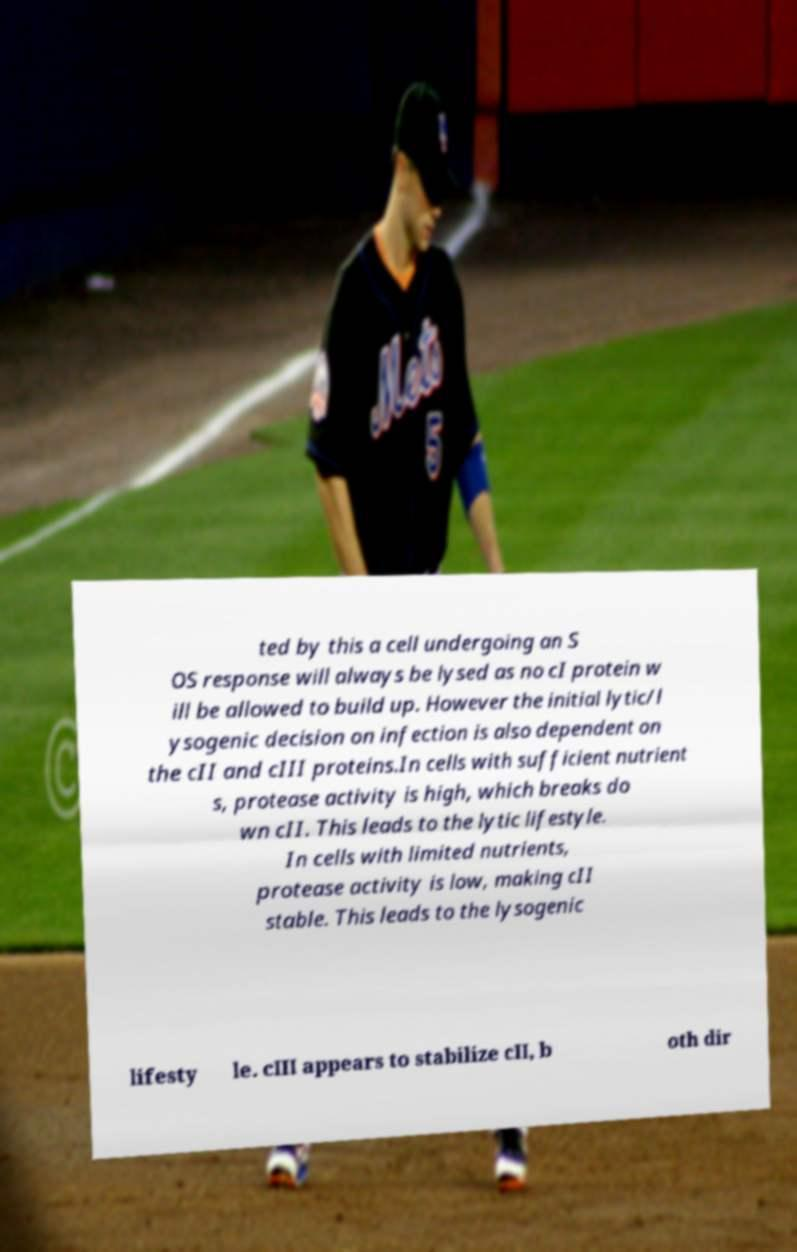Can you read and provide the text displayed in the image?This photo seems to have some interesting text. Can you extract and type it out for me? ted by this a cell undergoing an S OS response will always be lysed as no cI protein w ill be allowed to build up. However the initial lytic/l ysogenic decision on infection is also dependent on the cII and cIII proteins.In cells with sufficient nutrient s, protease activity is high, which breaks do wn cII. This leads to the lytic lifestyle. In cells with limited nutrients, protease activity is low, making cII stable. This leads to the lysogenic lifesty le. cIII appears to stabilize cII, b oth dir 